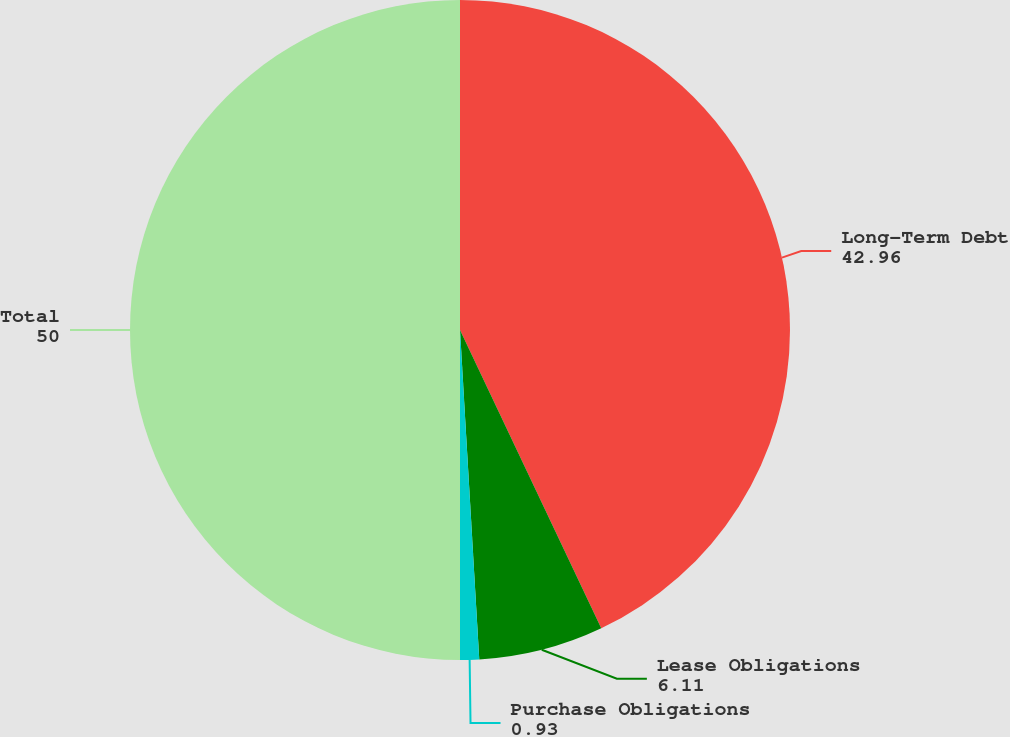<chart> <loc_0><loc_0><loc_500><loc_500><pie_chart><fcel>Long-Term Debt<fcel>Lease Obligations<fcel>Purchase Obligations<fcel>Total<nl><fcel>42.96%<fcel>6.11%<fcel>0.93%<fcel>50.0%<nl></chart> 